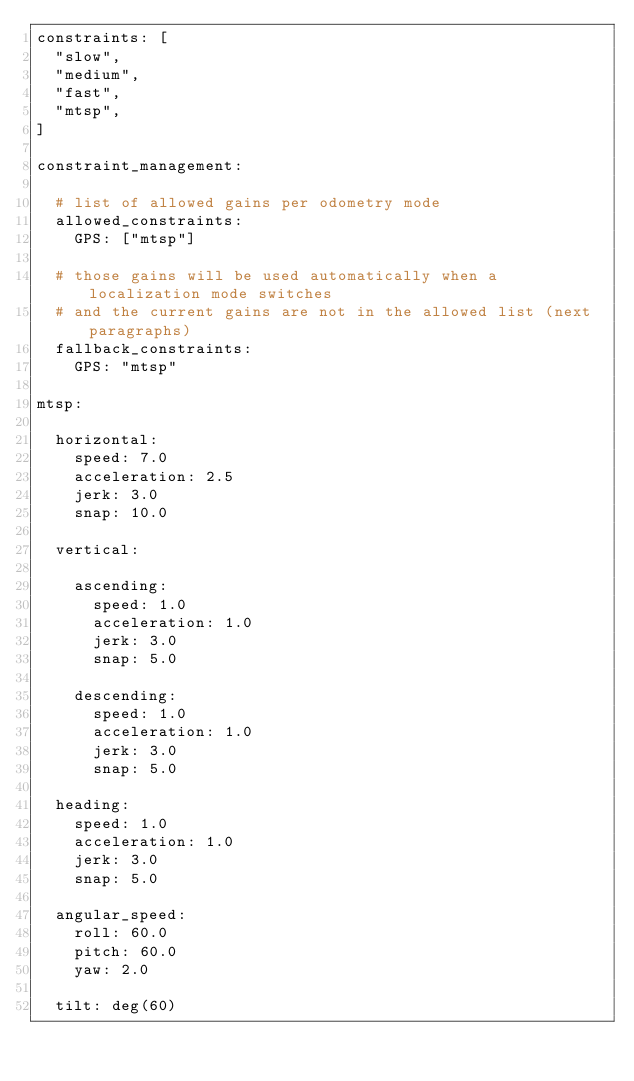Convert code to text. <code><loc_0><loc_0><loc_500><loc_500><_YAML_>constraints: [
  "slow",
  "medium",
  "fast",
  "mtsp",
]

constraint_management:

  # list of allowed gains per odometry mode
  allowed_constraints:
    GPS: ["mtsp"]

  # those gains will be used automatically when a localization mode switches
  # and the current gains are not in the allowed list (next paragraphs)
  fallback_constraints:
    GPS: "mtsp"

mtsp:

  horizontal:
    speed: 7.0
    acceleration: 2.5
    jerk: 3.0
    snap: 10.0

  vertical:

    ascending:
      speed: 1.0
      acceleration: 1.0
      jerk: 3.0
      snap: 5.0

    descending:
      speed: 1.0
      acceleration: 1.0
      jerk: 3.0
      snap: 5.0

  heading:
    speed: 1.0
    acceleration: 1.0
    jerk: 3.0
    snap: 5.0

  angular_speed:
    roll: 60.0
    pitch: 60.0
    yaw: 2.0

  tilt: deg(60)
</code> 